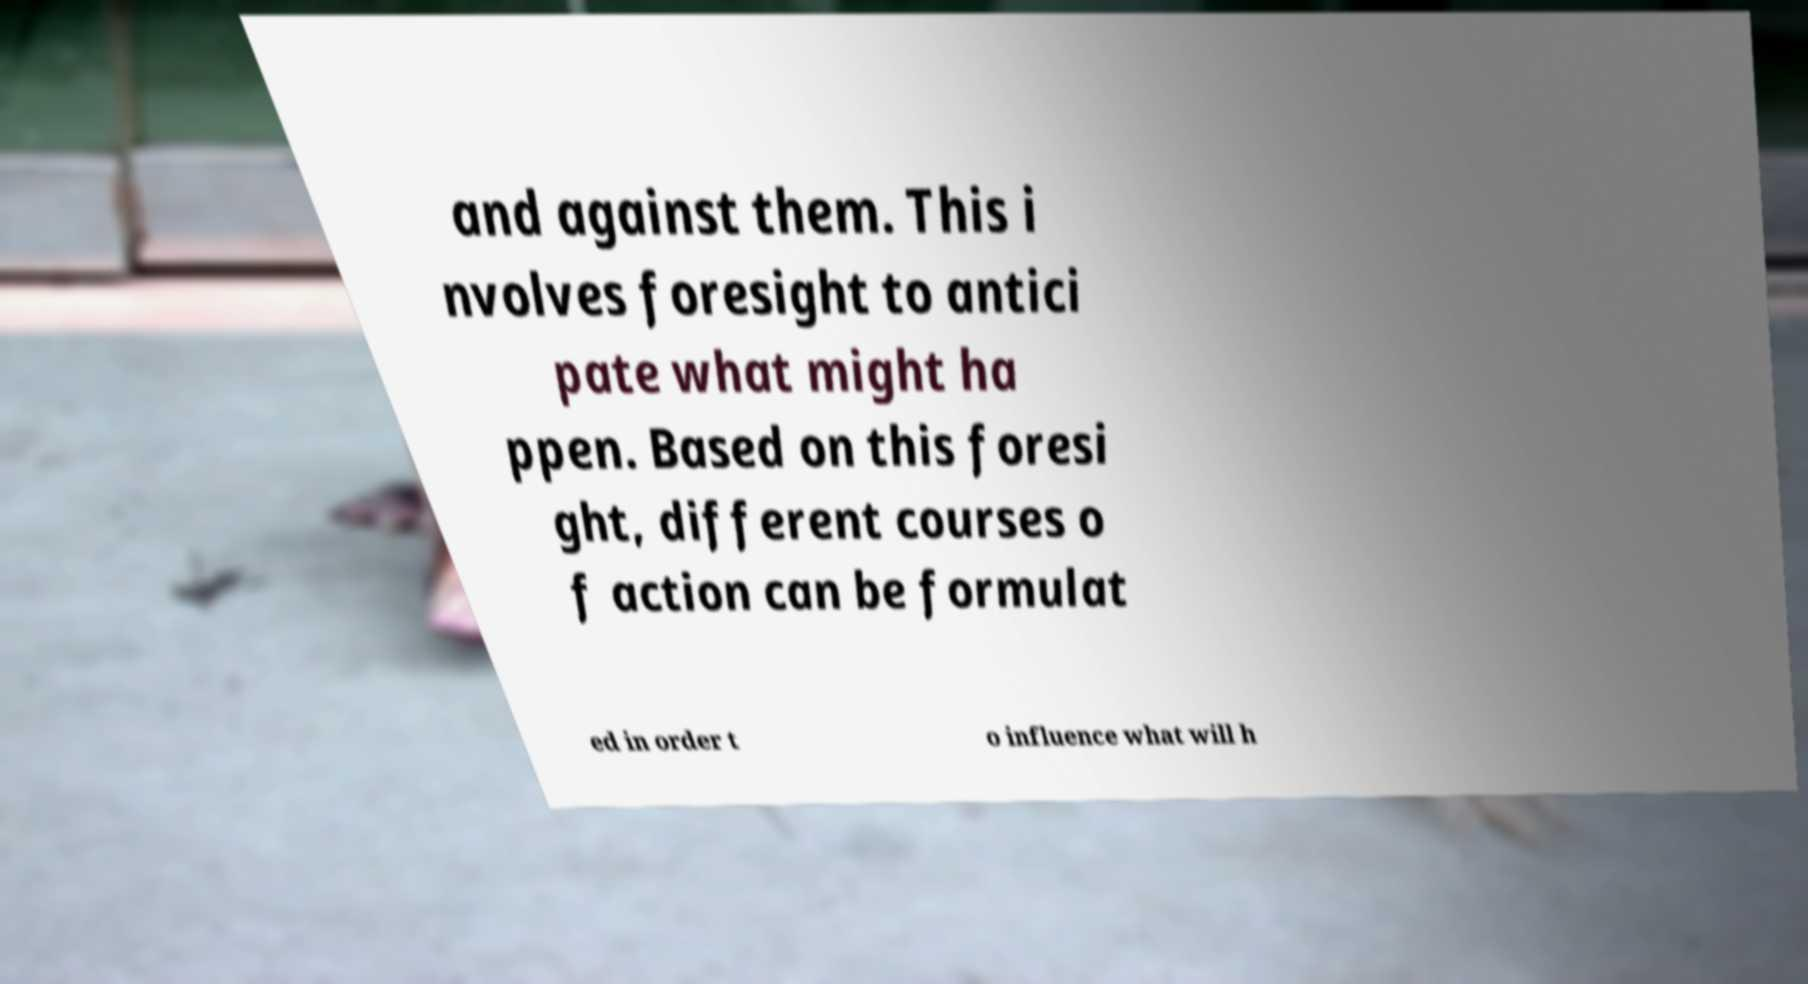Can you accurately transcribe the text from the provided image for me? and against them. This i nvolves foresight to antici pate what might ha ppen. Based on this foresi ght, different courses o f action can be formulat ed in order t o influence what will h 